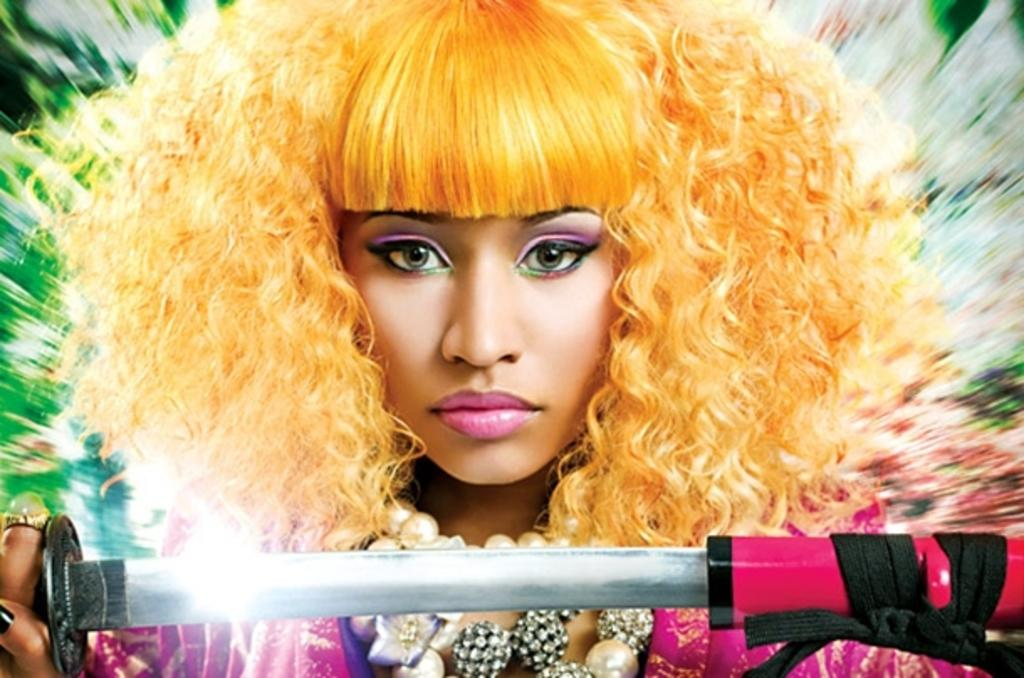Who is present in the image? There is a woman in the image. What is the woman holding in the image? The woman is holding a weapon. What is the woman doing in the image? The woman is watching something. How would you describe the clarity of the image? The image has a blurry view. What type of quartz can be seen in the woman's hand in the image? There is no quartz present in the image; the woman is holding a weapon. How does the popcorn appear in the image? There is no popcorn present in the image. 